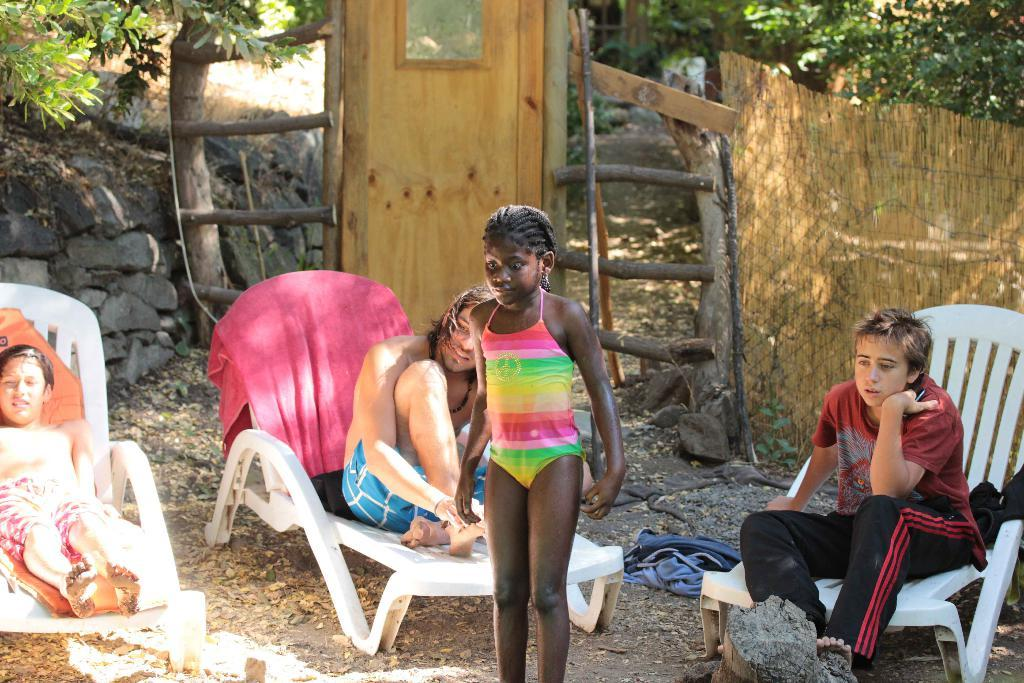What is the kid doing in the image? The kid is sitting on a chair in the image. What is the girl doing in the image? The girl is standing in the image. What is on the chair that the kid is sitting on? There are towels on the chair. What can be seen in the background of the image? There are trees visible in the background of the image. What type of structure is present in the image? There is a fencing in the image. What type of base is the kid using for their journey in the image? There is no journey or base present in the image; it simply shows a kid sitting on a chair with towels. 